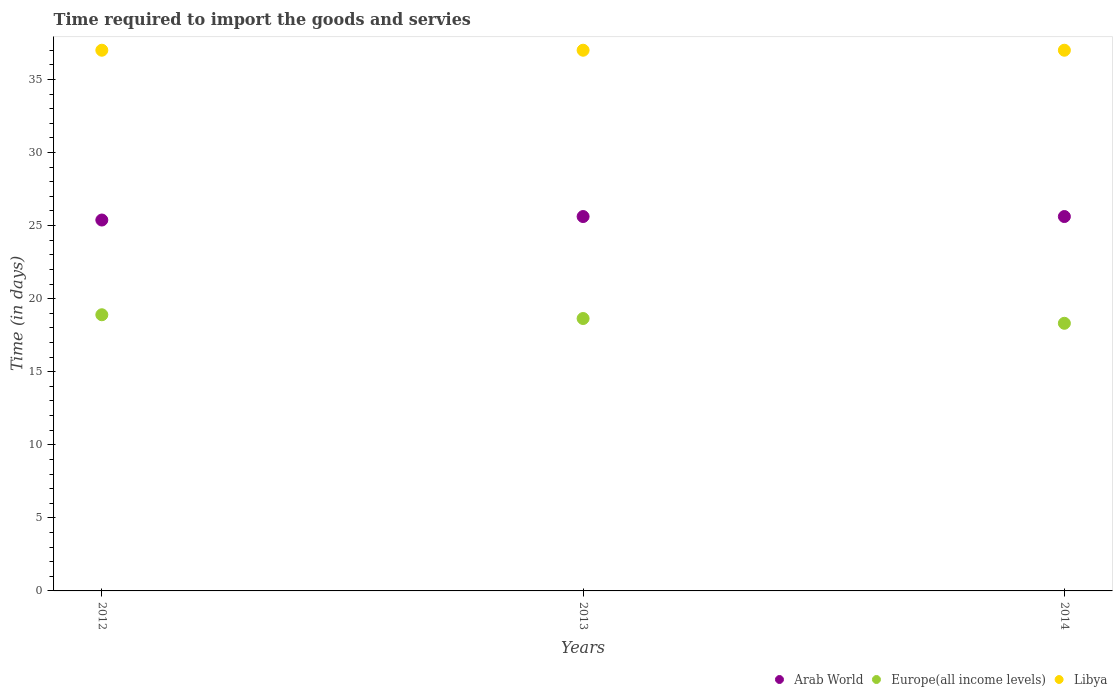What is the number of days required to import the goods and services in Europe(all income levels) in 2014?
Provide a short and direct response. 18.31. Across all years, what is the minimum number of days required to import the goods and services in Europe(all income levels)?
Offer a very short reply. 18.31. What is the total number of days required to import the goods and services in Arab World in the graph?
Give a very brief answer. 76.62. What is the difference between the number of days required to import the goods and services in Europe(all income levels) in 2014 and the number of days required to import the goods and services in Arab World in 2012?
Your response must be concise. -7.07. What is the average number of days required to import the goods and services in Arab World per year?
Give a very brief answer. 25.54. In the year 2013, what is the difference between the number of days required to import the goods and services in Arab World and number of days required to import the goods and services in Libya?
Make the answer very short. -11.38. In how many years, is the number of days required to import the goods and services in Europe(all income levels) greater than 29 days?
Offer a very short reply. 0. What is the ratio of the number of days required to import the goods and services in Europe(all income levels) in 2013 to that in 2014?
Offer a very short reply. 1.02. Is the number of days required to import the goods and services in Libya in 2013 less than that in 2014?
Your response must be concise. No. What is the difference between the highest and the second highest number of days required to import the goods and services in Europe(all income levels)?
Provide a short and direct response. 0.26. What is the difference between the highest and the lowest number of days required to import the goods and services in Europe(all income levels)?
Offer a terse response. 0.58. In how many years, is the number of days required to import the goods and services in Europe(all income levels) greater than the average number of days required to import the goods and services in Europe(all income levels) taken over all years?
Offer a very short reply. 2. Is the sum of the number of days required to import the goods and services in Arab World in 2012 and 2013 greater than the maximum number of days required to import the goods and services in Libya across all years?
Keep it short and to the point. Yes. Is it the case that in every year, the sum of the number of days required to import the goods and services in Europe(all income levels) and number of days required to import the goods and services in Arab World  is greater than the number of days required to import the goods and services in Libya?
Provide a succinct answer. Yes. Does the number of days required to import the goods and services in Europe(all income levels) monotonically increase over the years?
Your answer should be compact. No. Is the number of days required to import the goods and services in Libya strictly greater than the number of days required to import the goods and services in Europe(all income levels) over the years?
Your answer should be compact. Yes. Is the number of days required to import the goods and services in Europe(all income levels) strictly less than the number of days required to import the goods and services in Libya over the years?
Offer a very short reply. Yes. How many years are there in the graph?
Keep it short and to the point. 3. What is the difference between two consecutive major ticks on the Y-axis?
Give a very brief answer. 5. Are the values on the major ticks of Y-axis written in scientific E-notation?
Make the answer very short. No. How many legend labels are there?
Your answer should be very brief. 3. How are the legend labels stacked?
Keep it short and to the point. Horizontal. What is the title of the graph?
Give a very brief answer. Time required to import the goods and servies. Does "Netherlands" appear as one of the legend labels in the graph?
Provide a succinct answer. No. What is the label or title of the X-axis?
Keep it short and to the point. Years. What is the label or title of the Y-axis?
Make the answer very short. Time (in days). What is the Time (in days) in Arab World in 2012?
Your answer should be very brief. 25.38. What is the Time (in days) of Europe(all income levels) in 2012?
Give a very brief answer. 18.9. What is the Time (in days) in Libya in 2012?
Your answer should be compact. 37. What is the Time (in days) of Arab World in 2013?
Your response must be concise. 25.62. What is the Time (in days) in Europe(all income levels) in 2013?
Offer a terse response. 18.64. What is the Time (in days) in Libya in 2013?
Keep it short and to the point. 37. What is the Time (in days) in Arab World in 2014?
Give a very brief answer. 25.62. What is the Time (in days) of Europe(all income levels) in 2014?
Keep it short and to the point. 18.31. What is the Time (in days) of Libya in 2014?
Make the answer very short. 37. Across all years, what is the maximum Time (in days) in Arab World?
Your answer should be very brief. 25.62. Across all years, what is the maximum Time (in days) in Europe(all income levels)?
Ensure brevity in your answer.  18.9. Across all years, what is the maximum Time (in days) in Libya?
Your answer should be compact. 37. Across all years, what is the minimum Time (in days) in Arab World?
Your response must be concise. 25.38. Across all years, what is the minimum Time (in days) in Europe(all income levels)?
Ensure brevity in your answer.  18.31. What is the total Time (in days) of Arab World in the graph?
Provide a short and direct response. 76.62. What is the total Time (in days) in Europe(all income levels) in the graph?
Keep it short and to the point. 55.85. What is the total Time (in days) in Libya in the graph?
Offer a very short reply. 111. What is the difference between the Time (in days) in Arab World in 2012 and that in 2013?
Provide a short and direct response. -0.24. What is the difference between the Time (in days) of Europe(all income levels) in 2012 and that in 2013?
Your response must be concise. 0.26. What is the difference between the Time (in days) in Arab World in 2012 and that in 2014?
Offer a terse response. -0.24. What is the difference between the Time (in days) of Europe(all income levels) in 2012 and that in 2014?
Keep it short and to the point. 0.58. What is the difference between the Time (in days) in Libya in 2012 and that in 2014?
Offer a very short reply. 0. What is the difference between the Time (in days) in Europe(all income levels) in 2013 and that in 2014?
Your answer should be compact. 0.33. What is the difference between the Time (in days) in Libya in 2013 and that in 2014?
Your answer should be very brief. 0. What is the difference between the Time (in days) of Arab World in 2012 and the Time (in days) of Europe(all income levels) in 2013?
Your answer should be very brief. 6.74. What is the difference between the Time (in days) in Arab World in 2012 and the Time (in days) in Libya in 2013?
Your answer should be very brief. -11.62. What is the difference between the Time (in days) in Europe(all income levels) in 2012 and the Time (in days) in Libya in 2013?
Keep it short and to the point. -18.1. What is the difference between the Time (in days) of Arab World in 2012 and the Time (in days) of Europe(all income levels) in 2014?
Offer a terse response. 7.07. What is the difference between the Time (in days) in Arab World in 2012 and the Time (in days) in Libya in 2014?
Ensure brevity in your answer.  -11.62. What is the difference between the Time (in days) of Europe(all income levels) in 2012 and the Time (in days) of Libya in 2014?
Ensure brevity in your answer.  -18.1. What is the difference between the Time (in days) in Arab World in 2013 and the Time (in days) in Europe(all income levels) in 2014?
Your answer should be very brief. 7.3. What is the difference between the Time (in days) in Arab World in 2013 and the Time (in days) in Libya in 2014?
Provide a succinct answer. -11.38. What is the difference between the Time (in days) of Europe(all income levels) in 2013 and the Time (in days) of Libya in 2014?
Offer a very short reply. -18.36. What is the average Time (in days) of Arab World per year?
Keep it short and to the point. 25.54. What is the average Time (in days) in Europe(all income levels) per year?
Offer a very short reply. 18.62. What is the average Time (in days) in Libya per year?
Offer a terse response. 37. In the year 2012, what is the difference between the Time (in days) of Arab World and Time (in days) of Europe(all income levels)?
Provide a short and direct response. 6.48. In the year 2012, what is the difference between the Time (in days) of Arab World and Time (in days) of Libya?
Keep it short and to the point. -11.62. In the year 2012, what is the difference between the Time (in days) in Europe(all income levels) and Time (in days) in Libya?
Your response must be concise. -18.1. In the year 2013, what is the difference between the Time (in days) in Arab World and Time (in days) in Europe(all income levels)?
Your response must be concise. 6.98. In the year 2013, what is the difference between the Time (in days) of Arab World and Time (in days) of Libya?
Offer a very short reply. -11.38. In the year 2013, what is the difference between the Time (in days) in Europe(all income levels) and Time (in days) in Libya?
Provide a short and direct response. -18.36. In the year 2014, what is the difference between the Time (in days) of Arab World and Time (in days) of Europe(all income levels)?
Your answer should be compact. 7.3. In the year 2014, what is the difference between the Time (in days) of Arab World and Time (in days) of Libya?
Provide a short and direct response. -11.38. In the year 2014, what is the difference between the Time (in days) of Europe(all income levels) and Time (in days) of Libya?
Offer a terse response. -18.69. What is the ratio of the Time (in days) in Arab World in 2012 to that in 2013?
Make the answer very short. 0.99. What is the ratio of the Time (in days) of Europe(all income levels) in 2012 to that in 2013?
Your answer should be very brief. 1.01. What is the ratio of the Time (in days) of Europe(all income levels) in 2012 to that in 2014?
Keep it short and to the point. 1.03. What is the ratio of the Time (in days) in Libya in 2012 to that in 2014?
Your answer should be compact. 1. What is the ratio of the Time (in days) of Arab World in 2013 to that in 2014?
Ensure brevity in your answer.  1. What is the ratio of the Time (in days) of Europe(all income levels) in 2013 to that in 2014?
Offer a very short reply. 1.02. What is the difference between the highest and the second highest Time (in days) of Europe(all income levels)?
Your response must be concise. 0.26. What is the difference between the highest and the second highest Time (in days) in Libya?
Keep it short and to the point. 0. What is the difference between the highest and the lowest Time (in days) in Arab World?
Give a very brief answer. 0.24. What is the difference between the highest and the lowest Time (in days) in Europe(all income levels)?
Offer a very short reply. 0.58. What is the difference between the highest and the lowest Time (in days) of Libya?
Make the answer very short. 0. 